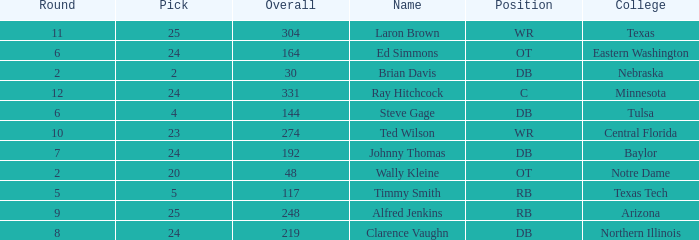What are the total rounds for the texas college and has a pick smaller than 25? 0.0. 